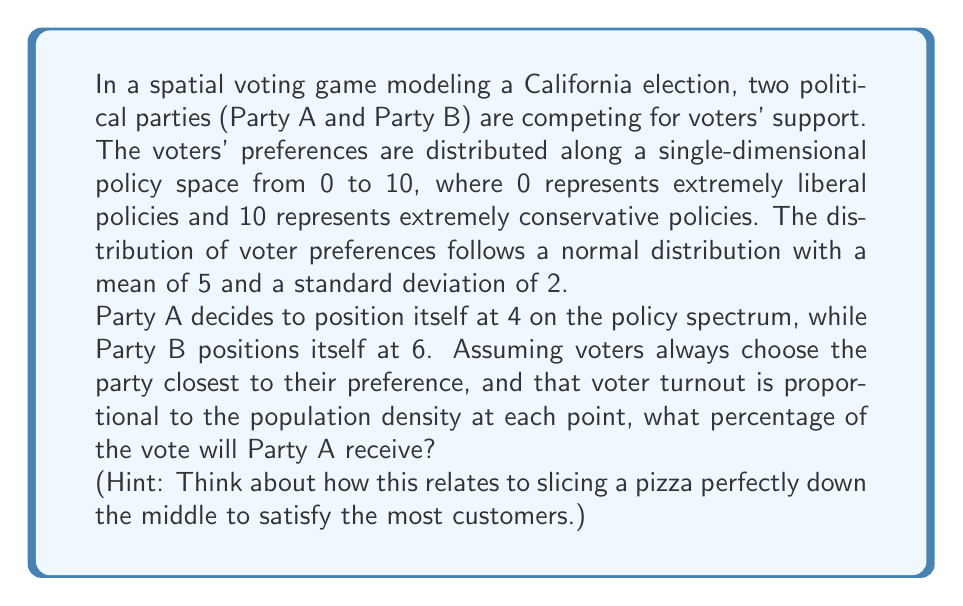Could you help me with this problem? To solve this problem, we need to follow these steps:

1) First, we need to understand that the dividing point between voters who prefer Party A and those who prefer Party B is exactly halfway between their positions: $(4 + 6) / 2 = 5$.

2) This means that all voters with preferences below 5 will vote for Party A, and all voters with preferences above 5 will vote for Party B.

3) Since the voter preferences follow a normal distribution with mean $\mu = 5$ and standard deviation $\sigma = 2$, we need to find the area under the normal curve to the left of 5.

4) In a standard normal distribution (mean 0, standard deviation 1), this would be equivalent to finding the area to the left of z = 0, where:

   $$z = \frac{x - \mu}{\sigma} = \frac{5 - 5}{2} = 0$$

5) The area to the left of z = 0 in a standard normal distribution is exactly 0.5 or 50%.

6) This means that Party A will receive 50% of the vote, and Party B will also receive 50%.

This result is analogous to cutting a pizza exactly down the middle - each half satisfies an equal number of customers. In this political "pizza", both parties have positioned themselves to capture exactly half of the voter "slices".
Answer: Party A will receive 50% of the vote. 